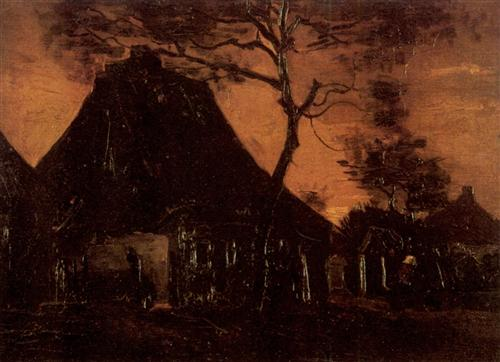Imagine living in this landscape. What would a day in the life be like? Living in this landscape would likely be bleak and quiet, surrounded by palpable silence and a sense of isolation. Days might begin early, with the dim light of dawn struggling to penetrate the dense, dark sky. The wind would whistle through the barren tree, and the abandoned cottage, once full of life, now stands as a decaying relic. Daily life could involve foraging for resources, seeking shelter within the sturdy but empty walls of the cottage, and trying to find warmth as the dark, orange sky forebodes an impending twilight. The absence of other human presence would amplify the desolation, making every creak of the tree and rustle of the wind a companion in this lonely existence. What kind of people might have lived here once? The people who once lived in this cottage were likely simple folk, perhaps a small family of farmers or homesteaders. Their daily lives revolved around the cycles of the seasons, working the land during the day and returning to the warmth of the cottage in the evenings. The large thatched roof suggests that it was built to withstand harsh weather, indicating self-reliance and ingenuity. Over time, as perhaps resources dwindled or better opportunities arose elsewhere, they might have moved on, leaving behind the vestiges of their hard-earned life. Their departure turned the cottage into the abandoned shell it is now, a silent testament to a bygone chapter filled with labor, living, and the eventual surrender to nature's reclamation. 